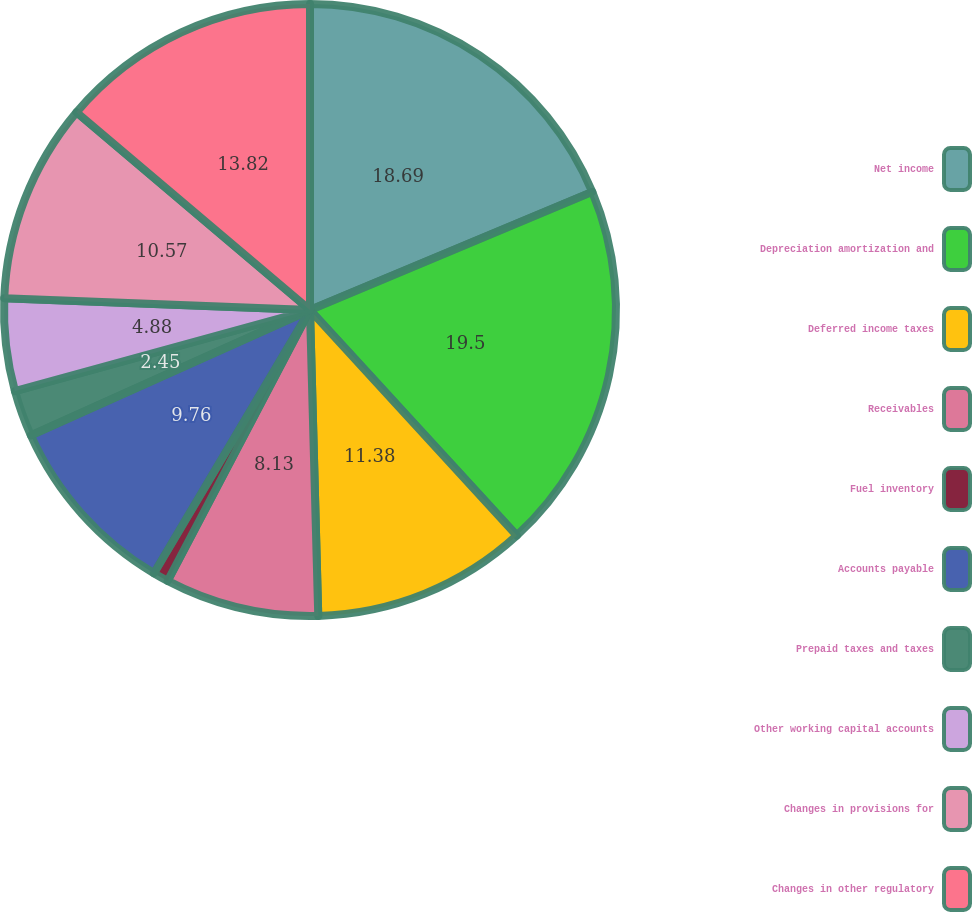Convert chart. <chart><loc_0><loc_0><loc_500><loc_500><pie_chart><fcel>Net income<fcel>Depreciation amortization and<fcel>Deferred income taxes<fcel>Receivables<fcel>Fuel inventory<fcel>Accounts payable<fcel>Prepaid taxes and taxes<fcel>Other working capital accounts<fcel>Changes in provisions for<fcel>Changes in other regulatory<nl><fcel>18.69%<fcel>19.5%<fcel>11.38%<fcel>8.13%<fcel>0.82%<fcel>9.76%<fcel>2.45%<fcel>4.88%<fcel>10.57%<fcel>13.82%<nl></chart> 